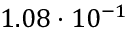Convert formula to latex. <formula><loc_0><loc_0><loc_500><loc_500>1 . 0 8 \cdot 1 0 ^ { - 1 }</formula> 